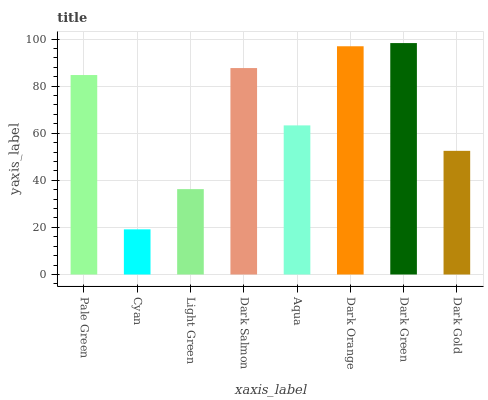Is Cyan the minimum?
Answer yes or no. Yes. Is Dark Green the maximum?
Answer yes or no. Yes. Is Light Green the minimum?
Answer yes or no. No. Is Light Green the maximum?
Answer yes or no. No. Is Light Green greater than Cyan?
Answer yes or no. Yes. Is Cyan less than Light Green?
Answer yes or no. Yes. Is Cyan greater than Light Green?
Answer yes or no. No. Is Light Green less than Cyan?
Answer yes or no. No. Is Pale Green the high median?
Answer yes or no. Yes. Is Aqua the low median?
Answer yes or no. Yes. Is Light Green the high median?
Answer yes or no. No. Is Pale Green the low median?
Answer yes or no. No. 